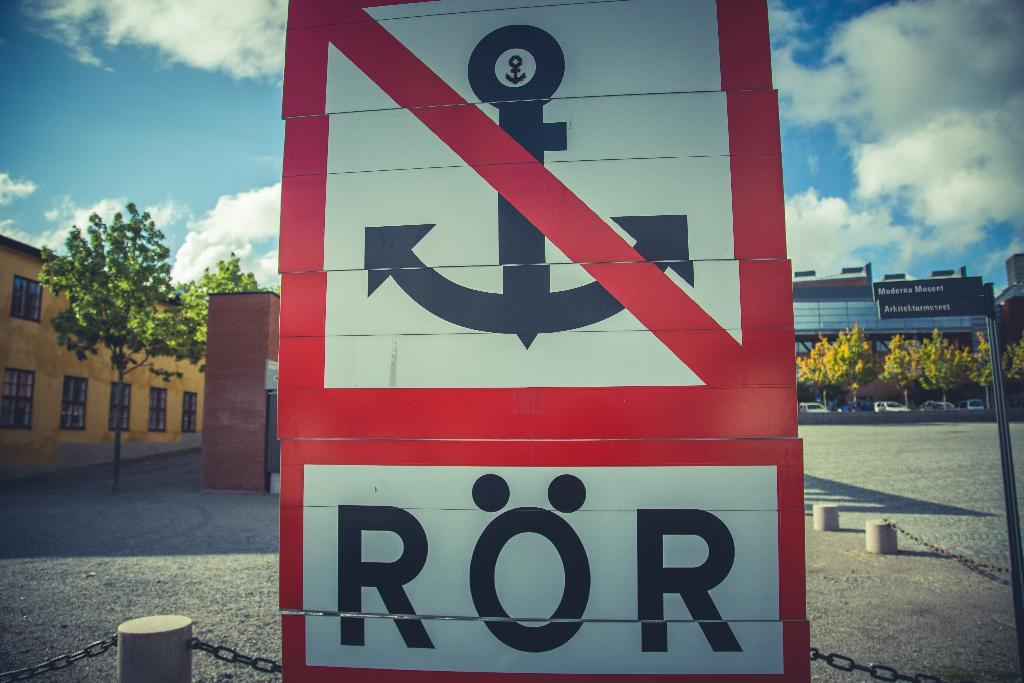Provide a one-sentence caption for the provided image. A sign with the word "RÖR" at the bottom and an anchor above it that is crossed out in red. 